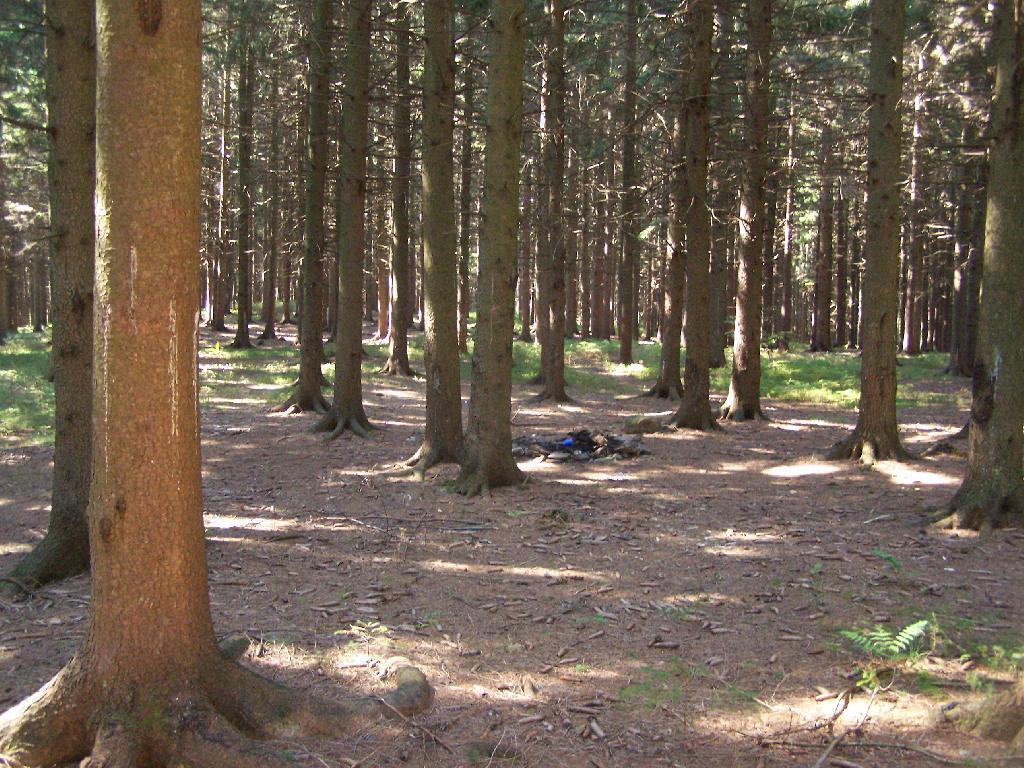What type of vegetation can be seen in the image? There are trees and tree trunks in the image. What is the ground covered with in the image? There is grass in the image. How many chickens are visible in the image? There are no chickens present in the image. What type of bag can be seen hanging from the tree trunks? There is no bag present in the image. 